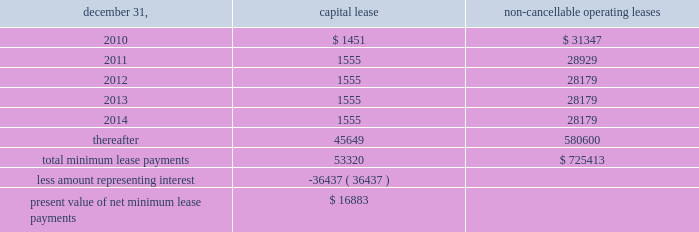Notes to consolidated financial statements of annual compensation was made .
For the years ended december 31 , 2009 , 2008 and , 2007 , we made matching contributions of approxi- mately $ 450000 , $ 503000 and $ 457000 , respectively .
Note 17 / commitments and contingencies we and our operating partnership are not presently involved in any mate- rial litigation nor , to our knowledge , is any material litigation threatened against us or our properties , other than routine litigation arising in the ordinary course of business .
Management believes the costs , if any , incurred by us and our operating partnership related to this litigation will not materially affect our financial position , operating results or liquidity .
We have entered into employment agreements with certain executives , which expire between june 2010 and january 2013 .
The minimum cash-based compensation , including base salary and guaran- teed bonus payments , associated with these employment agreements totals approximately $ 7.8 million for 2010 .
In march 1998 , we acquired an operating sub-leasehold posi- tion at 420 lexington avenue .
The operating sub-leasehold position required annual ground lease payments totaling $ 6.0 million and sub- leasehold position payments totaling $ 1.1 million ( excluding an operating sub-lease position purchased january 1999 ) .
In june 2007 , we renewed and extended the maturity date of the ground lease at 420 lexington avenue through december 31 , 2029 , with an option for further exten- sion through 2080 .
Ground lease rent payments through 2029 will total approximately $ 10.9 million per year .
Thereafter , the ground lease will be subject to a revaluation by the parties thereto .
In june 2009 , we acquired an operating sub-leasehold posi- tion at 420 lexington avenue for approximately $ 7.7 million .
These sub-leasehold positions were scheduled to mature in december 2029 .
In october 2009 , we acquired the remaining sub-leasehold position for $ 7.6 million .
The property located at 711 third avenue operates under an operating sub-lease , which expires in 2083 .
Under the sub-lease , we are responsible for ground rent payments of $ 1.55 million annually through july 2011 on the 50% ( 50 % ) portion of the fee we do not own .
The ground rent is reset after july 2011 based on the estimated fair market value of the property .
We have an option to buy out the sub-lease at a fixed future date .
The property located at 461 fifth avenue operates under a ground lease ( approximately $ 2.1 million annually ) with a term expiration date of 2027 and with two options to renew for an additional 21 years each , followed by a third option for 15 years .
We also have an option to purchase the ground lease for a fixed price on a specific date .
The property located at 625 madison avenue operates under a ground lease ( approximately $ 4.6 million annually ) with a term expiration date of 2022 and with two options to renew for an additional 23 years .
The property located at 1185 avenue of the americas oper- ates under a ground lease ( approximately $ 8.5 million in 2010 and $ 6.9 million annually thereafter ) with a term expiration of 2020 and with an option to renew for an additional 23 years .
In april 1988 , the sl green predecessor entered into a lease agreement for the property at 673 first avenue , which has been capitalized for financial statement purposes .
Land was estimated to be approximately 70% ( 70 % ) of the fair market value of the property .
The portion of the lease attributed to land is classified as an operating lease and the remainder as a capital lease .
The initial lease term is 49 years with an option for an additional 26 years .
Beginning in lease years 11 and 25 , the lessor is entitled to additional rent as defined by the lease agreement .
We continue to lease the 673 first avenue property , which has been classified as a capital lease with a cost basis of $ 12.2 million and cumulative amortization of $ 5.5 million and $ 5.2 million at december 31 , 2009 and 2008 , respectively .
The following is a schedule of future minimum lease payments under capital leases and noncancellable operating leases with initial terms in excess of one year as of december 31 , 2009 ( in thousands ) : non-cancellable december 31 , capital lease operating leases .
Note 18 / financial instruments : derivatives and hedging we recognize all derivatives on the balance sheet at fair value .
Derivatives that are not hedges must be adjusted to fair value through income .
If a derivative is a hedge , depending on the nature of the hedge , changes in the fair value of the derivative will either be offset against the change in fair value of the hedged asset , liability , or firm commitment through earn- ings , or recognized in other comprehensive income until the hedged item is recognized in earnings .
The ineffective portion of a derivative 2019s change in fair value will be immediately recognized in earnings .
Reported net income and stockholders 2019 equity may increase or decrease prospectively , depending on future levels of interest rates and other variables affecting the fair values of derivative instruments and hedged items , but will have no effect on cash flows. .
In 2009 what was the percent of the capital leases of the total future minimum lease payments that were due in 2012? 
Computations: (1555 / (1555 + 28179))
Answer: 0.0523. 